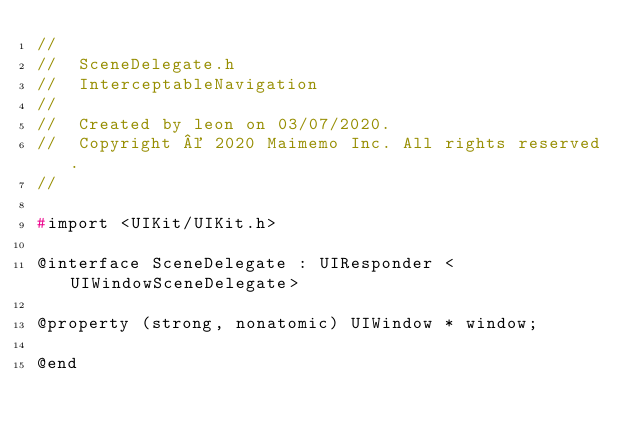<code> <loc_0><loc_0><loc_500><loc_500><_C_>//
//  SceneDelegate.h
//  InterceptableNavigation
//
//  Created by leon on 03/07/2020.
//  Copyright © 2020 Maimemo Inc. All rights reserved.
//

#import <UIKit/UIKit.h>

@interface SceneDelegate : UIResponder <UIWindowSceneDelegate>

@property (strong, nonatomic) UIWindow * window;

@end

</code> 